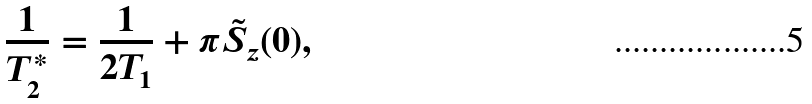Convert formula to latex. <formula><loc_0><loc_0><loc_500><loc_500>\frac { 1 } { T ^ { * } _ { 2 } } = \frac { 1 } { 2 T _ { 1 } } + \pi \tilde { S } _ { z } ( 0 ) ,</formula> 